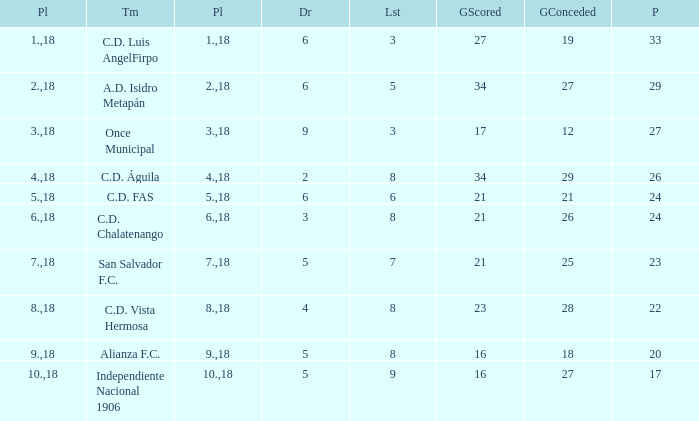For Once Municipal, what were the goals scored that had less than 27 points and greater than place 1? None. 